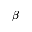Convert formula to latex. <formula><loc_0><loc_0><loc_500><loc_500>\beta</formula> 